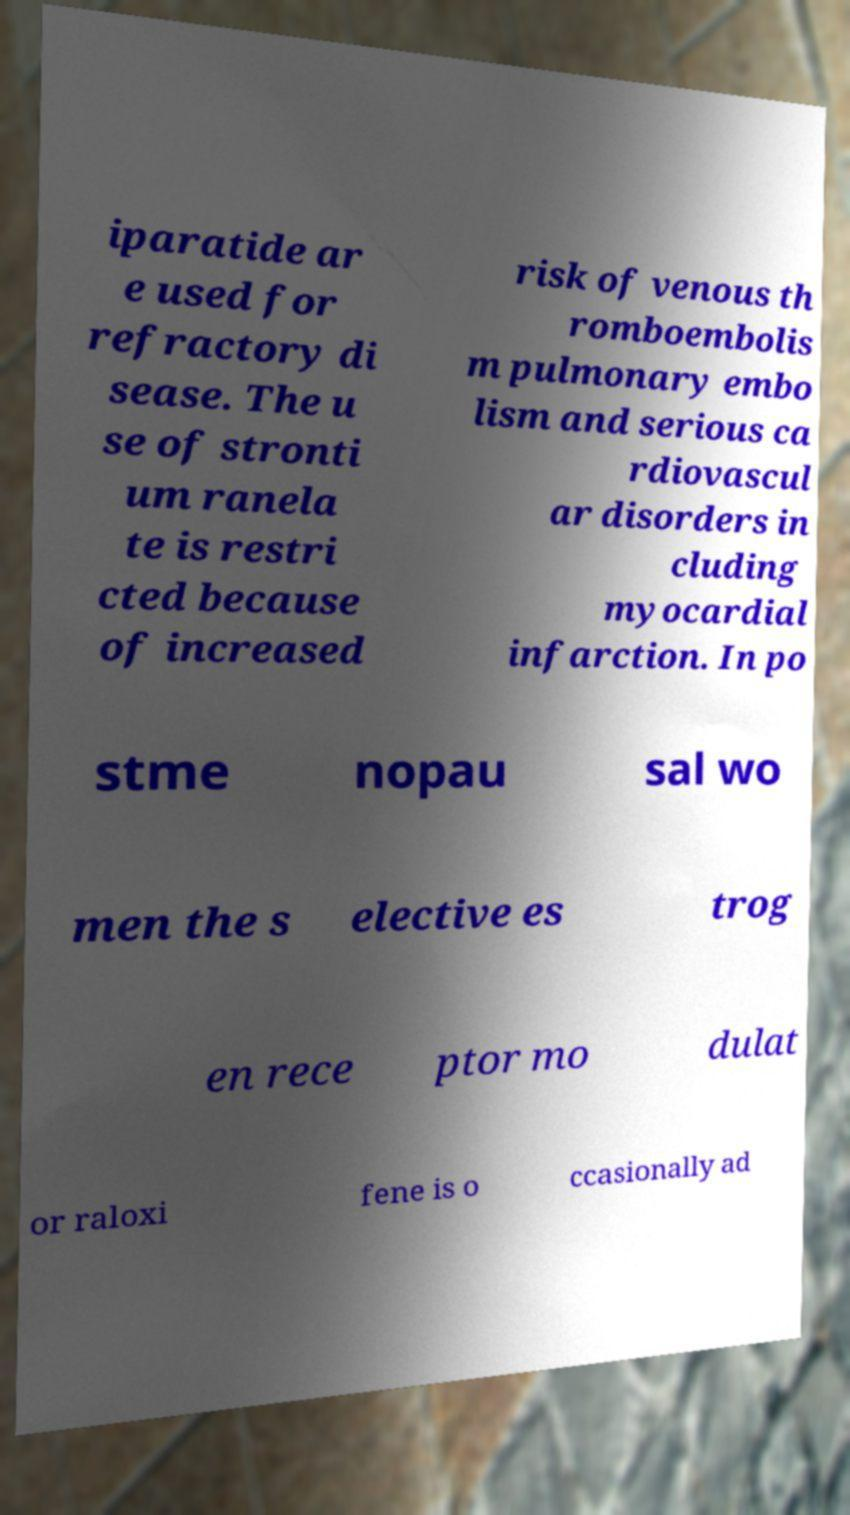Can you accurately transcribe the text from the provided image for me? iparatide ar e used for refractory di sease. The u se of stronti um ranela te is restri cted because of increased risk of venous th romboembolis m pulmonary embo lism and serious ca rdiovascul ar disorders in cluding myocardial infarction. In po stme nopau sal wo men the s elective es trog en rece ptor mo dulat or raloxi fene is o ccasionally ad 